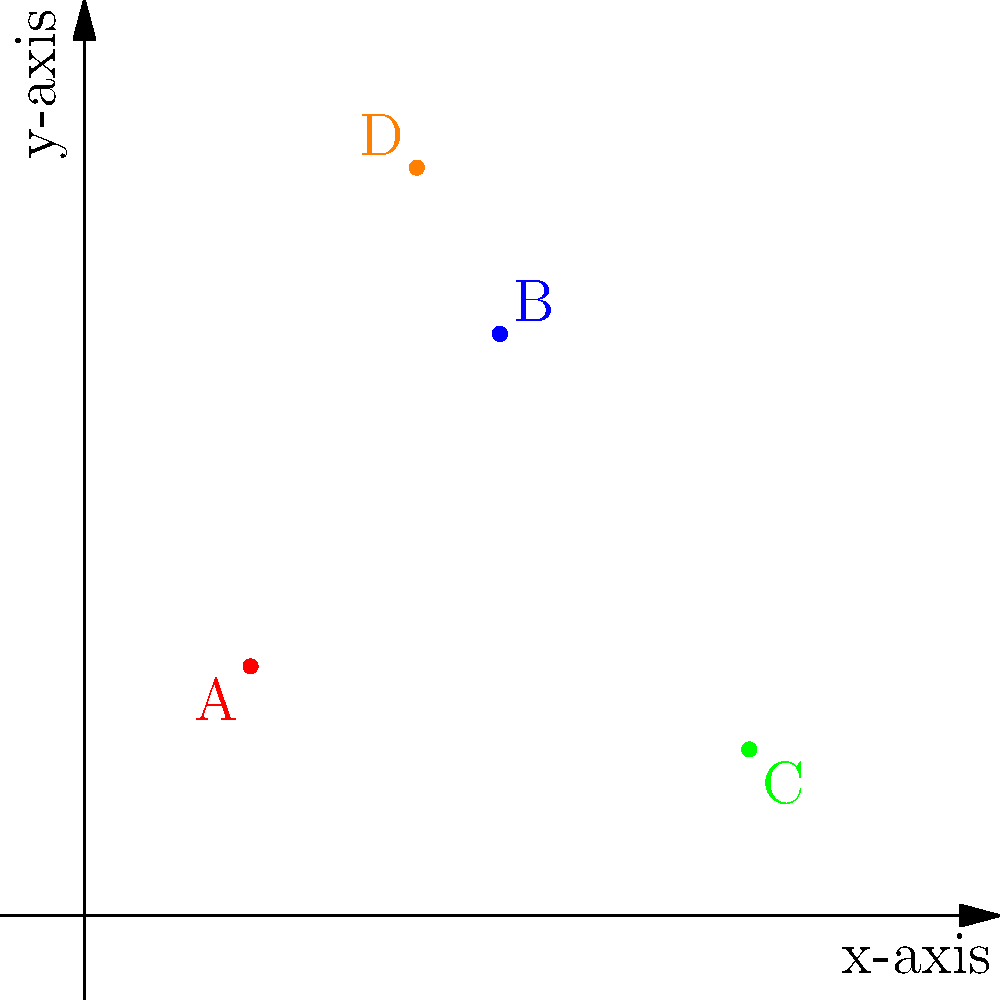In Ngqushwa, four local landmarks are plotted on a 2D coordinate plane. Point A (2,3) represents the Peddie Town Hall, B (5,7) the Qeto Dam, C (8,2) the Hamburg Beach, and D (4,9) the Great Fish River Nature Reserve. What is the total distance between the Peddie Town Hall and the Hamburg Beach, measured in coordinate units? To find the distance between two points on a coordinate plane, we can use the distance formula:

$$d = \sqrt{(x_2 - x_1)^2 + (y_2 - y_1)^2}$$

Where $(x_1, y_1)$ is the first point and $(x_2, y_2)$ is the second point.

Step 1: Identify the coordinates
- Peddie Town Hall (A): $(2, 3)$
- Hamburg Beach (C): $(8, 2)$

Step 2: Apply the distance formula
$$d = \sqrt{(8 - 2)^2 + (2 - 3)^2}$$

Step 3: Simplify
$$d = \sqrt{6^2 + (-1)^2}$$
$$d = \sqrt{36 + 1}$$
$$d = \sqrt{37}$$

Step 4: Simplify the square root
The square root of 37 cannot be simplified further, so we leave it as $\sqrt{37}$.

Therefore, the distance between the Peddie Town Hall and Hamburg Beach is $\sqrt{37}$ coordinate units.
Answer: $\sqrt{37}$ coordinate units 